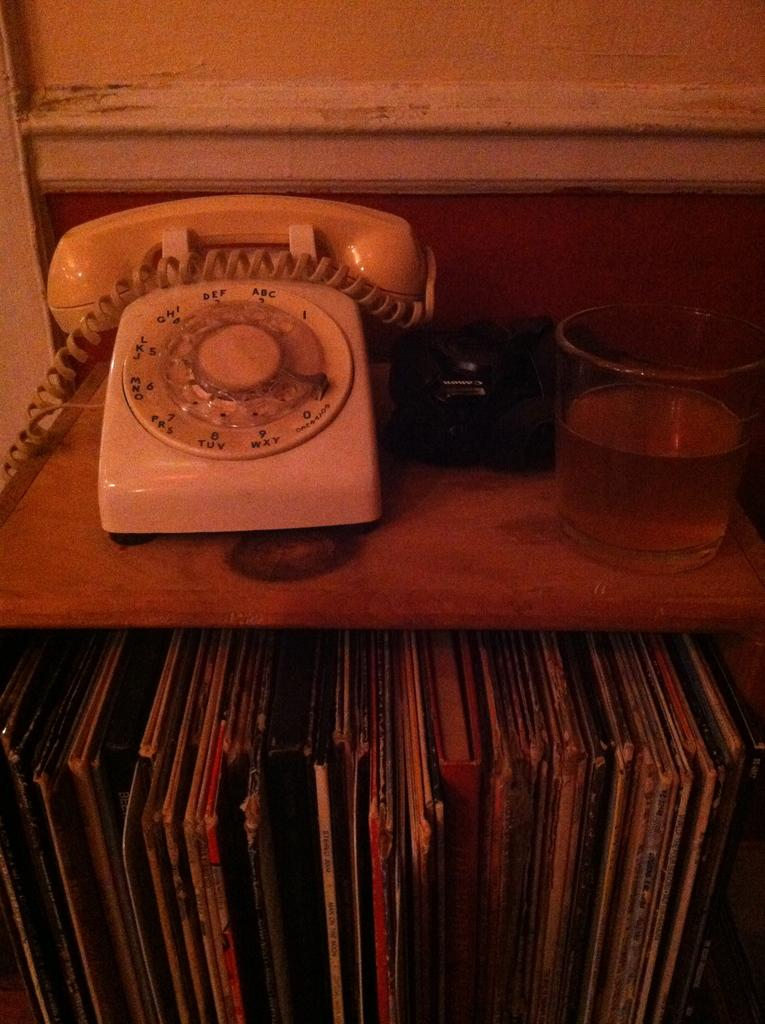<image>
Create a compact narrative representing the image presented. The letters under number 9 on the telephone are WXY. 